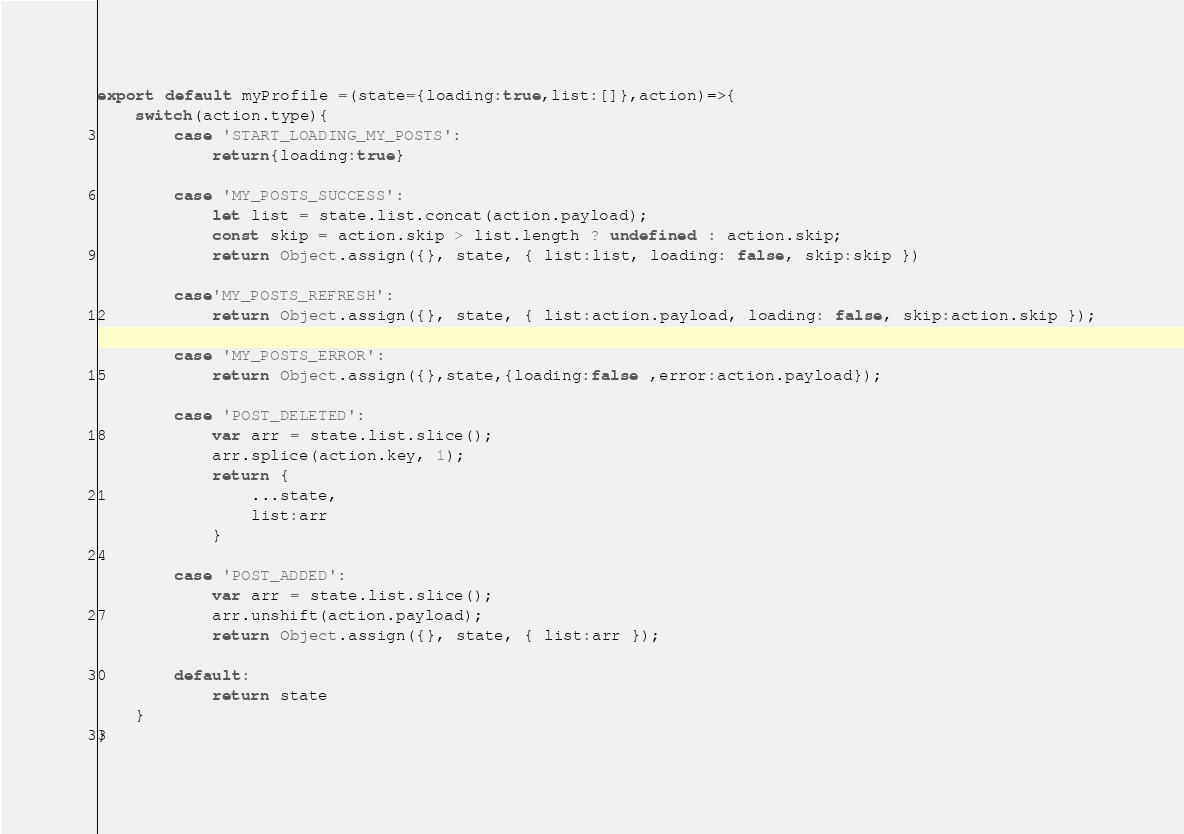Convert code to text. <code><loc_0><loc_0><loc_500><loc_500><_JavaScript_>export default myProfile =(state={loading:true,list:[]},action)=>{
    switch(action.type){
        case 'START_LOADING_MY_POSTS':
            return{loading:true}

        case 'MY_POSTS_SUCCESS':
            let list = state.list.concat(action.payload);
            const skip = action.skip > list.length ? undefined : action.skip;
            return Object.assign({}, state, { list:list, loading: false, skip:skip })

        case'MY_POSTS_REFRESH':
            return Object.assign({}, state, { list:action.payload, loading: false, skip:action.skip });

        case 'MY_POSTS_ERROR':
            return Object.assign({},state,{loading:false ,error:action.payload});

        case 'POST_DELETED':
            var arr = state.list.slice();
            arr.splice(action.key, 1);
            return {
                ...state,
                list:arr
            }

        case 'POST_ADDED':
            var arr = state.list.slice();
            arr.unshift(action.payload);
            return Object.assign({}, state, { list:arr });

        default:
            return state
    }
}</code> 